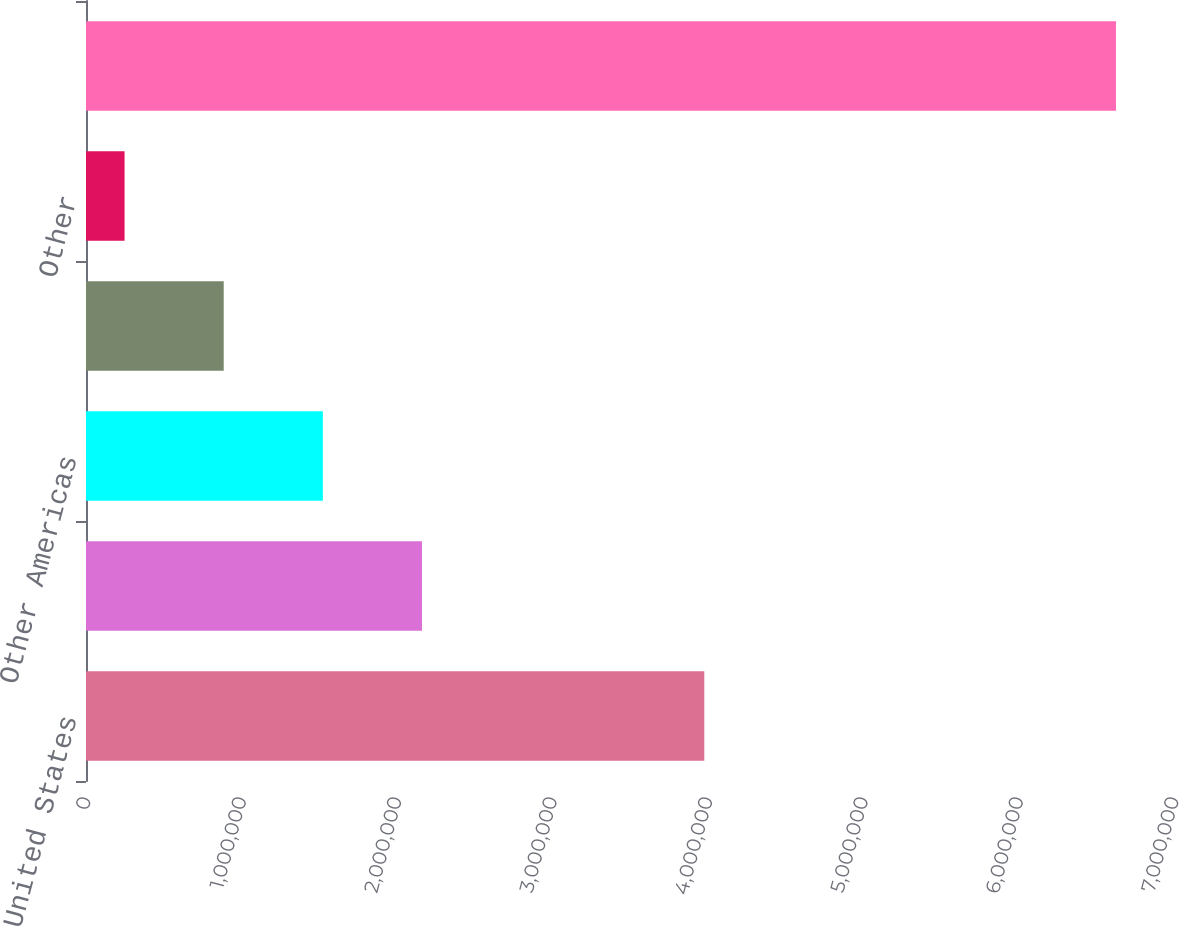<chart> <loc_0><loc_0><loc_500><loc_500><bar_chart><fcel>United States<fcel>Europe<fcel>Other Americas<fcel>Asia<fcel>Other<fcel>Consolidated total<nl><fcel>3.97792e+06<fcel>2.16172e+06<fcel>1.52387e+06<fcel>886028<fcel>248181<fcel>6.62665e+06<nl></chart> 